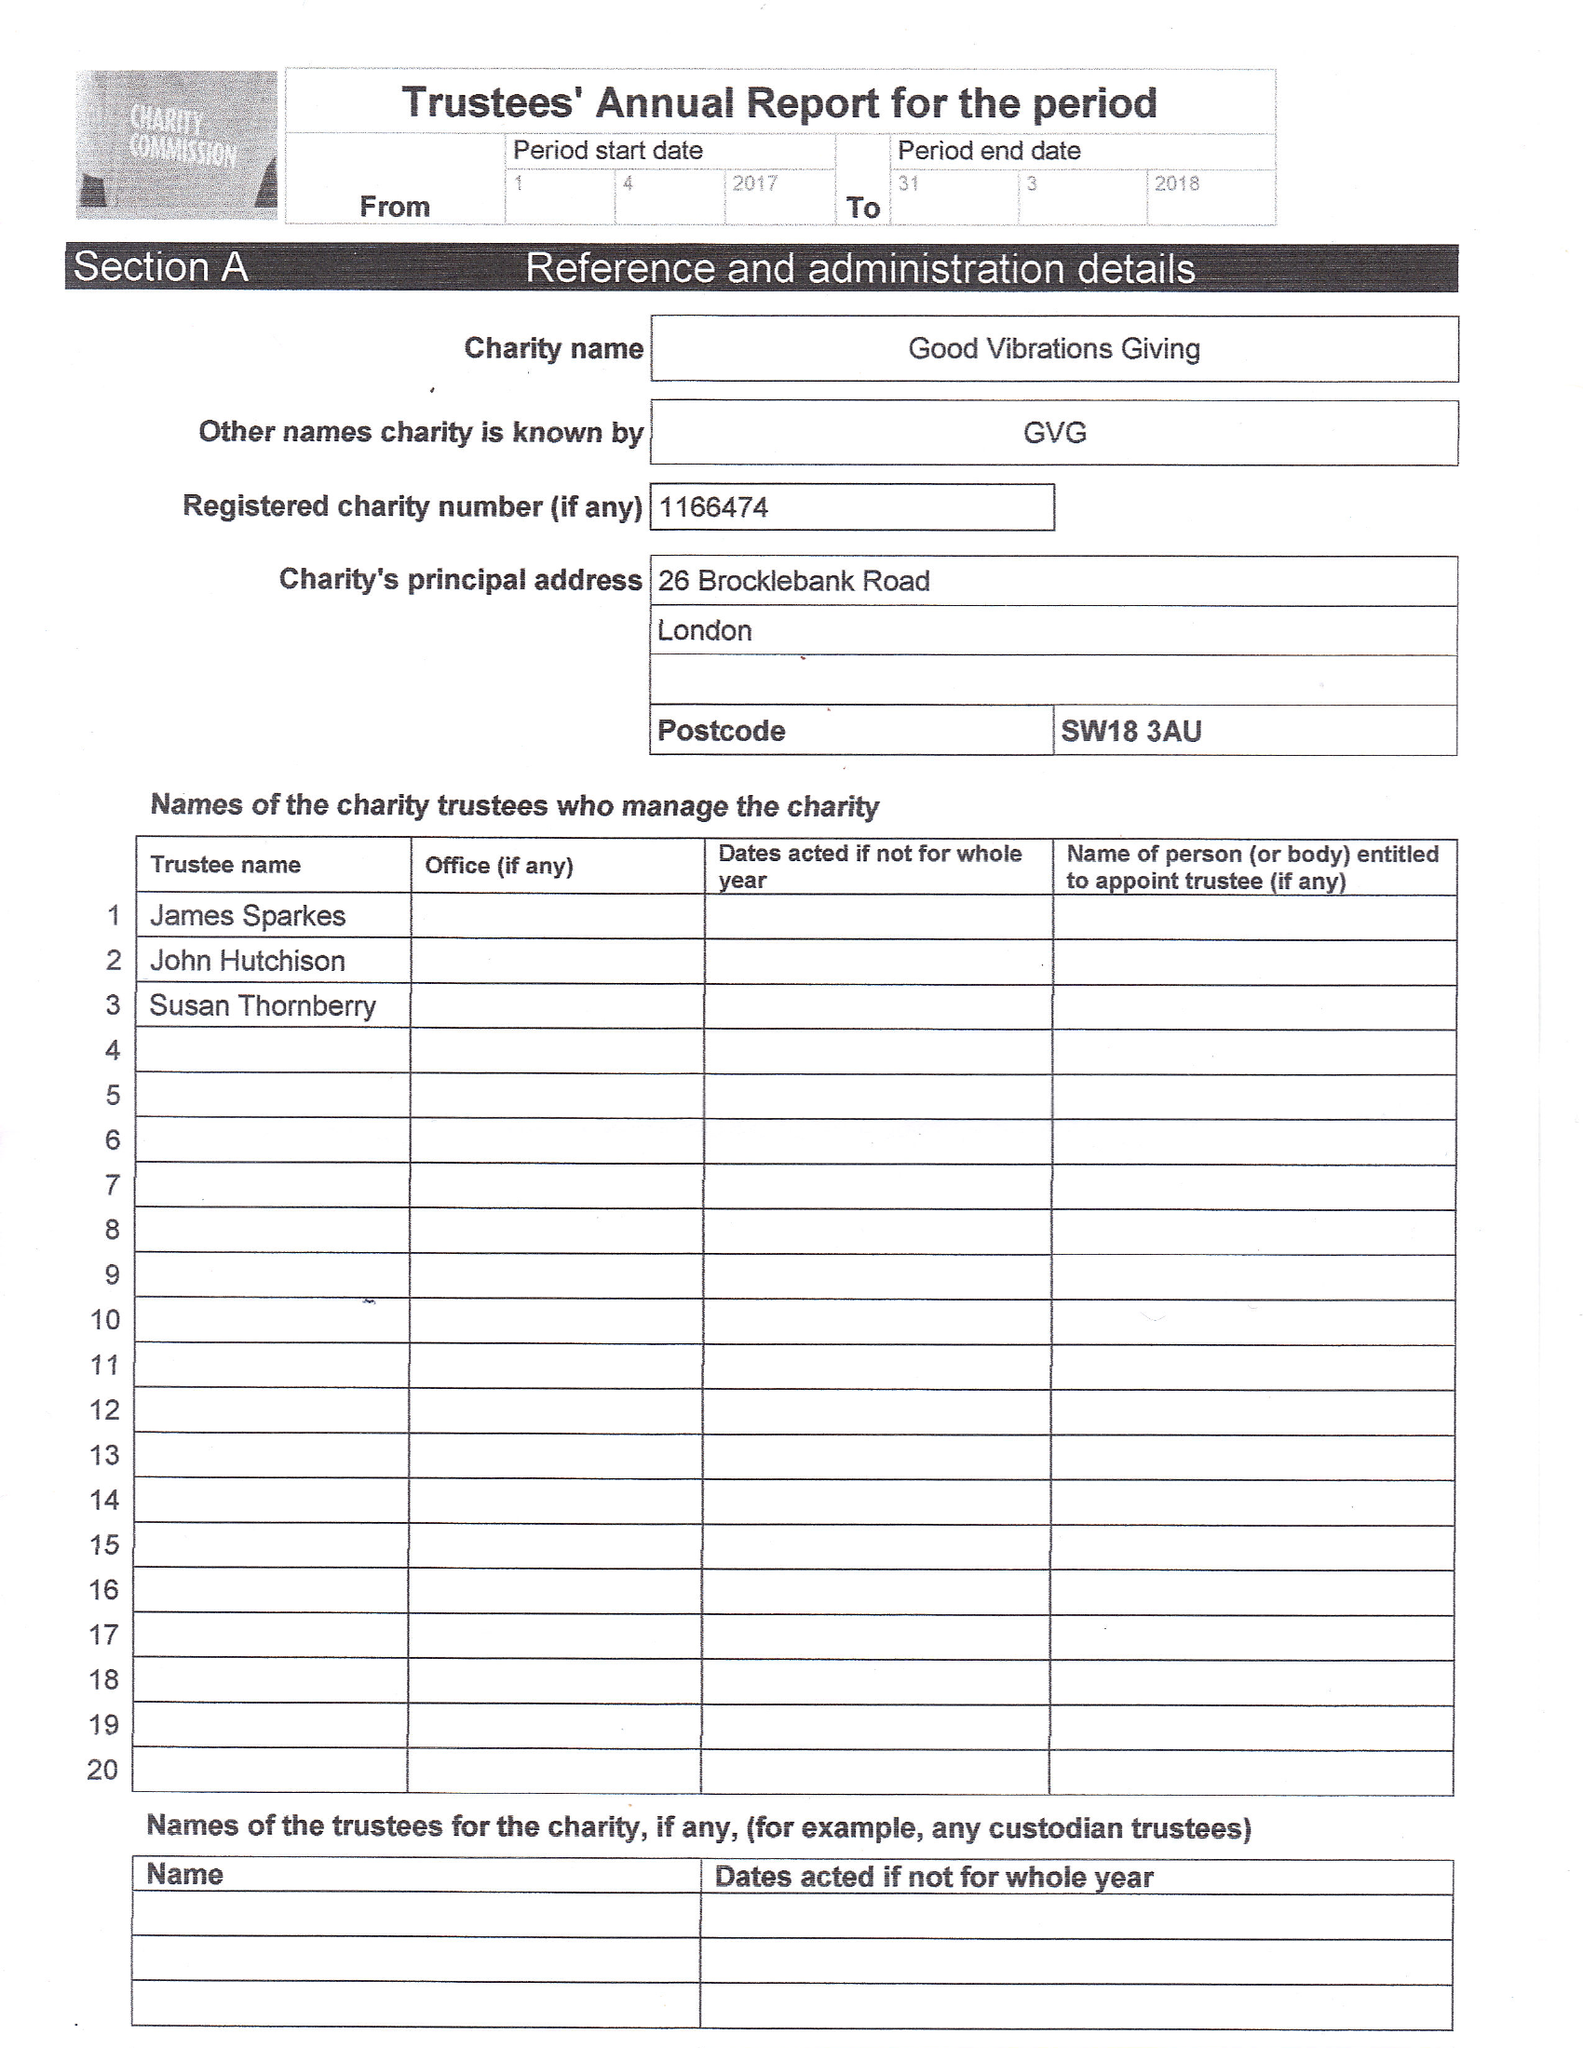What is the value for the spending_annually_in_british_pounds?
Answer the question using a single word or phrase. 6032.00 